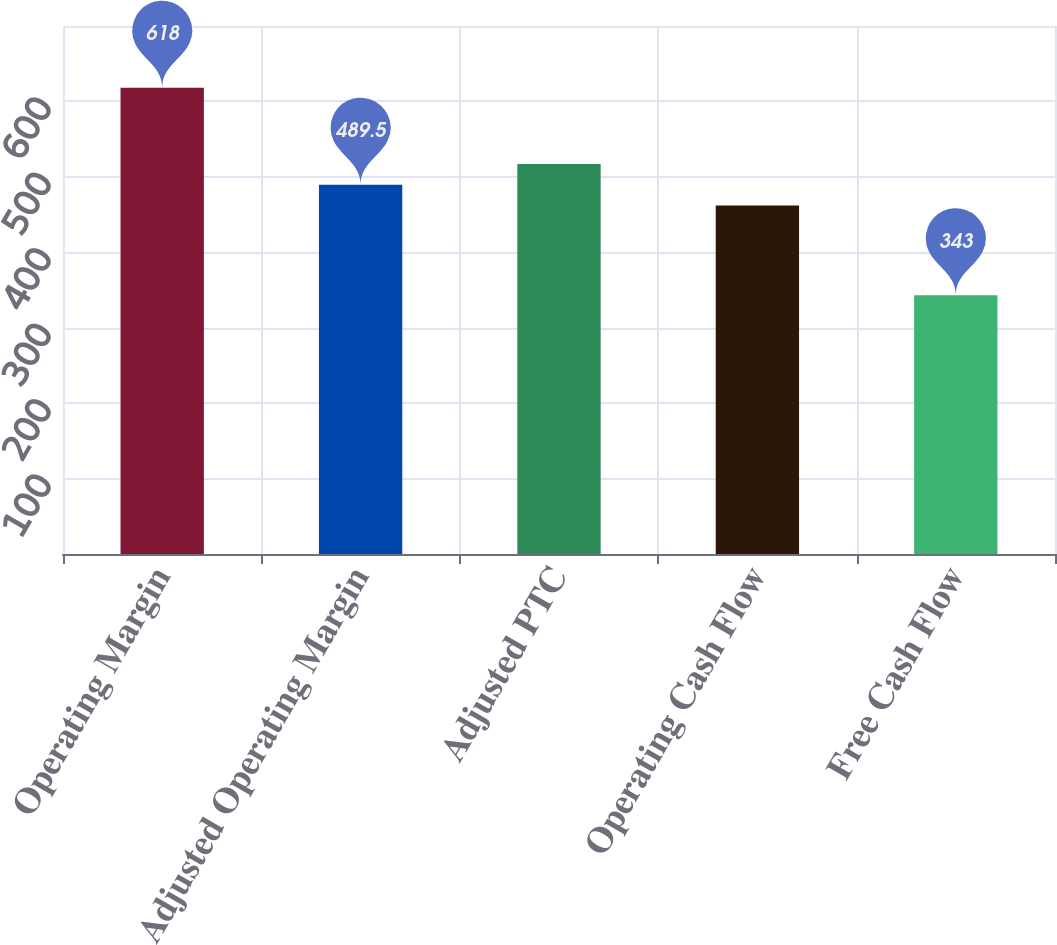Convert chart to OTSL. <chart><loc_0><loc_0><loc_500><loc_500><bar_chart><fcel>Operating Margin<fcel>Adjusted Operating Margin<fcel>Adjusted PTC<fcel>Operating Cash Flow<fcel>Free Cash Flow<nl><fcel>618<fcel>489.5<fcel>517<fcel>462<fcel>343<nl></chart> 